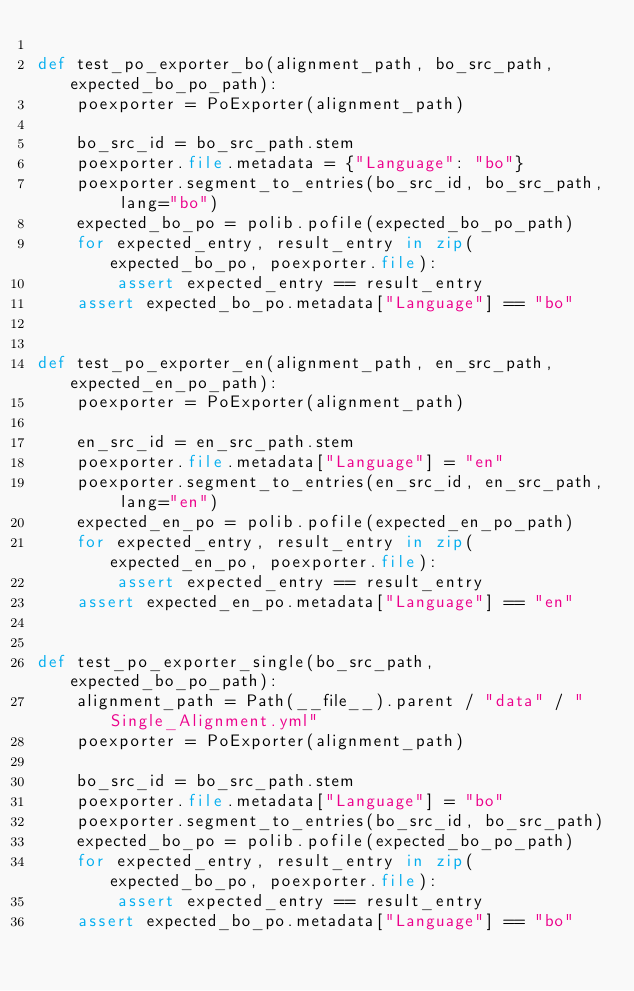Convert code to text. <code><loc_0><loc_0><loc_500><loc_500><_Python_>
def test_po_exporter_bo(alignment_path, bo_src_path, expected_bo_po_path):
    poexporter = PoExporter(alignment_path)

    bo_src_id = bo_src_path.stem
    poexporter.file.metadata = {"Language": "bo"}
    poexporter.segment_to_entries(bo_src_id, bo_src_path, lang="bo")
    expected_bo_po = polib.pofile(expected_bo_po_path)
    for expected_entry, result_entry in zip(expected_bo_po, poexporter.file):
        assert expected_entry == result_entry
    assert expected_bo_po.metadata["Language"] == "bo"


def test_po_exporter_en(alignment_path, en_src_path, expected_en_po_path):
    poexporter = PoExporter(alignment_path)

    en_src_id = en_src_path.stem
    poexporter.file.metadata["Language"] = "en"
    poexporter.segment_to_entries(en_src_id, en_src_path, lang="en")
    expected_en_po = polib.pofile(expected_en_po_path)
    for expected_entry, result_entry in zip(expected_en_po, poexporter.file):
        assert expected_entry == result_entry
    assert expected_en_po.metadata["Language"] == "en"


def test_po_exporter_single(bo_src_path, expected_bo_po_path):
    alignment_path = Path(__file__).parent / "data" / "Single_Alignment.yml"
    poexporter = PoExporter(alignment_path)

    bo_src_id = bo_src_path.stem
    poexporter.file.metadata["Language"] = "bo"
    poexporter.segment_to_entries(bo_src_id, bo_src_path)
    expected_bo_po = polib.pofile(expected_bo_po_path)
    for expected_entry, result_entry in zip(expected_bo_po, poexporter.file):
        assert expected_entry == result_entry
    assert expected_bo_po.metadata["Language"] == "bo"
</code> 